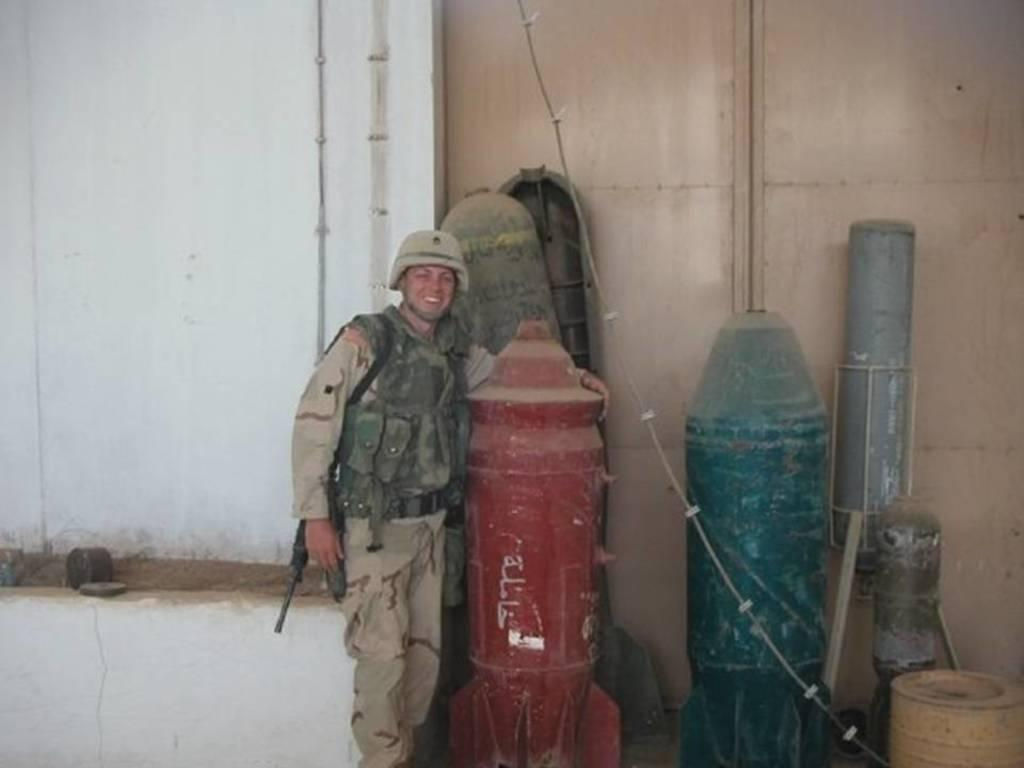What is the main subject of the image? There is a person standing in the center of the image. What is the person wearing? The person is wearing a helmet. What objects are near the person? There are missiles beside the person. What can be seen in the background of the image? There is a wall and a gate in the background of the image. What type of jelly can be seen on the wall in the image? There is no jelly present on the wall or anywhere else in the image. How did the earthquake affect the gate in the image? There is no mention of an earthquake in the image or the provided facts, so we cannot determine its effect on the gate. 